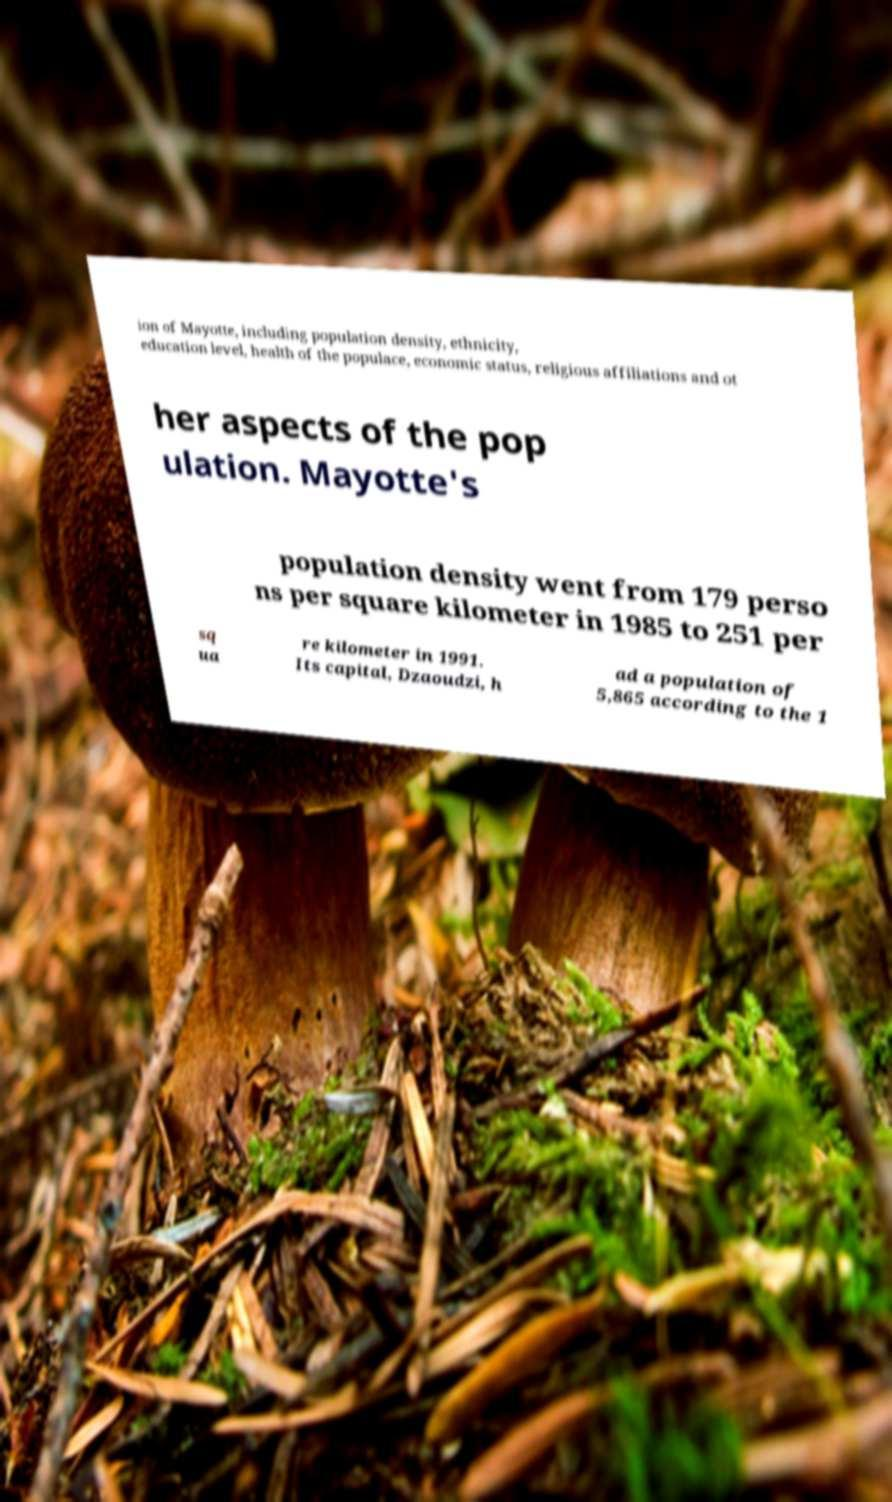What messages or text are displayed in this image? I need them in a readable, typed format. ion of Mayotte, including population density, ethnicity, education level, health of the populace, economic status, religious affiliations and ot her aspects of the pop ulation. Mayotte's population density went from 179 perso ns per square kilometer in 1985 to 251 per sq ua re kilometer in 1991. Its capital, Dzaoudzi, h ad a population of 5,865 according to the 1 